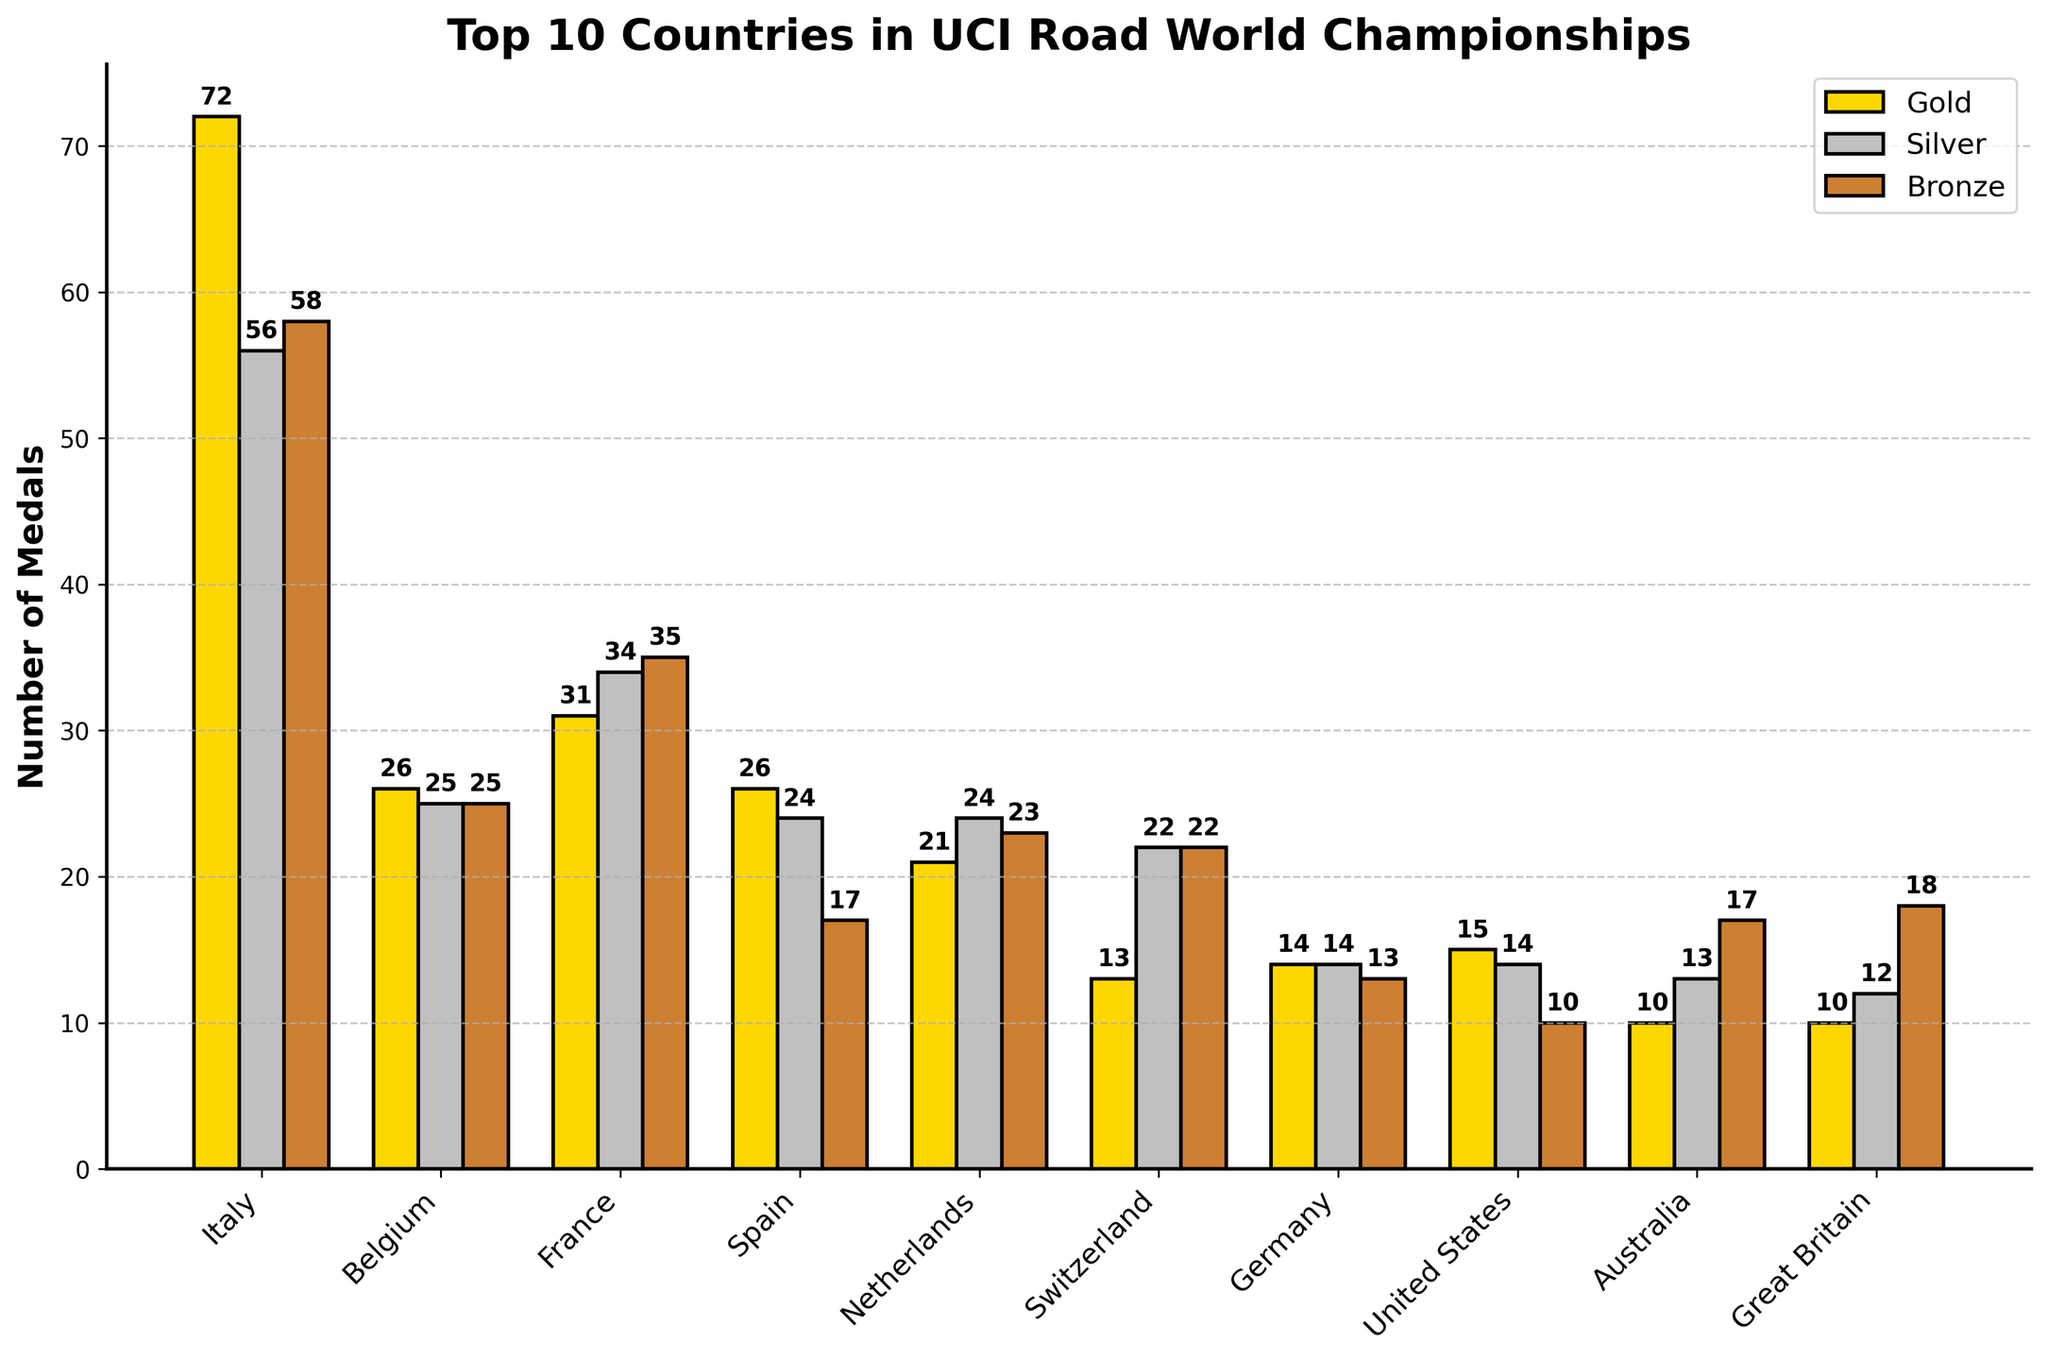Which country has the highest number of gold medals? From the chart, Italy has the tallest gold bar, indicating it has the highest number of gold medals compared to the other countries.
Answer: Italy How many total medals has France won? By summing the values of gold, silver, and bronze medals for France: 31 (gold) + 34 (silver) + 35 (bronze), the total number of medals is 31 + 34 + 35 = 100.
Answer: 100 Which country has more silver medals, Germany or Australia? Comparing the heights of the silver bars for Germany and Australia, Germany's bar reaches 14 while Australia's reaches 13.
Answer: Germany How many more bronze medals does the Netherlands have compared to the United States? The Netherlands has 23 bronze medals while the United States has 10, so the difference is 23 - 10 = 13.
Answer: 13 What is the average number of gold medals won by the top 10 countries? Summing all gold medals: 72 (Italy) + 26 (Belgium) + 31 (France) + 26 (Spain) + 21 (Netherlands) + 13 (Switzerland) + 14 (Germany) + 15 (United States) + 10 (Australia) + 10 (Great Britain) = 228. The average is 228 / 10 = 22.8.
Answer: 22.8 Which countries have an equal number of gold medals? Both Spain and Belgium have 26 gold medals each, as indicated by the equal height of their gold bars.
Answer: Spain, Belgium What is the ratio of silver to bronze medals for the United States? The United States has 14 silver medals and 10 bronze medals, so the ratio is 14 to 10, simplified to 7 to 5.
Answer: 7:5 Which country has the least number of gold medals? By comparing the heights of the gold bars, both Australia and Great Britain have the least, with 10 gold medals each.
Answer: Australia, Great Britain How many countries have more than 20 bronze medals? Counting the countries with bronze medal counts over 20: Italy (58), France (35), Netherlands (23), and Great Britain (18) does not qualify as it is below the threshold. Only Italy, France, and the Netherlands do.
Answer: 3 If you sum the total number of medals won by Belgium and Switzerland, what is the result? Adding up all medals for Belgium: 26 (gold) + 25 (silver) + 25 (bronze) = 76, and for Switzerland: 13 (gold) + 22 (silver) + 22 (bronze) = 57. The sum is 76 + 57 = 133.
Answer: 133 